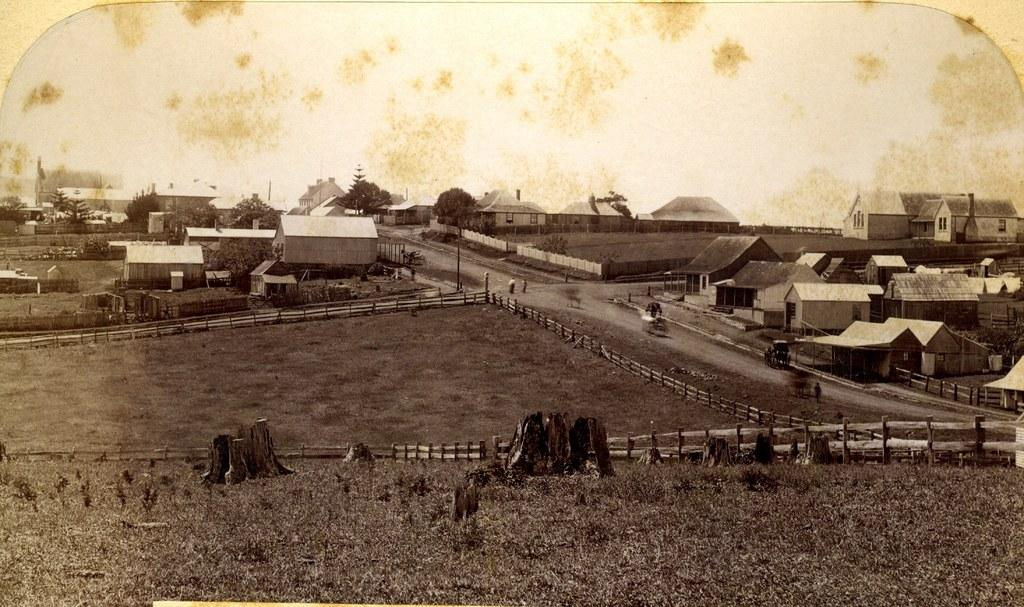What type of structures can be seen in the image? There are buildings in the image. Are there any living beings present in the image? Yes, there are persons in the image. What type of vegetation is visible in the image? There are trees in the image. What covers the ground in the front of the image? There is grass on the ground in the front of the image. Can you see a snake slithering through the grass in the image? There is no snake present in the image; it only features buildings, persons, trees, and grass. What type of string is being used to tie the trees together in the image? There is no string or any indication of trees being tied together in the image. 